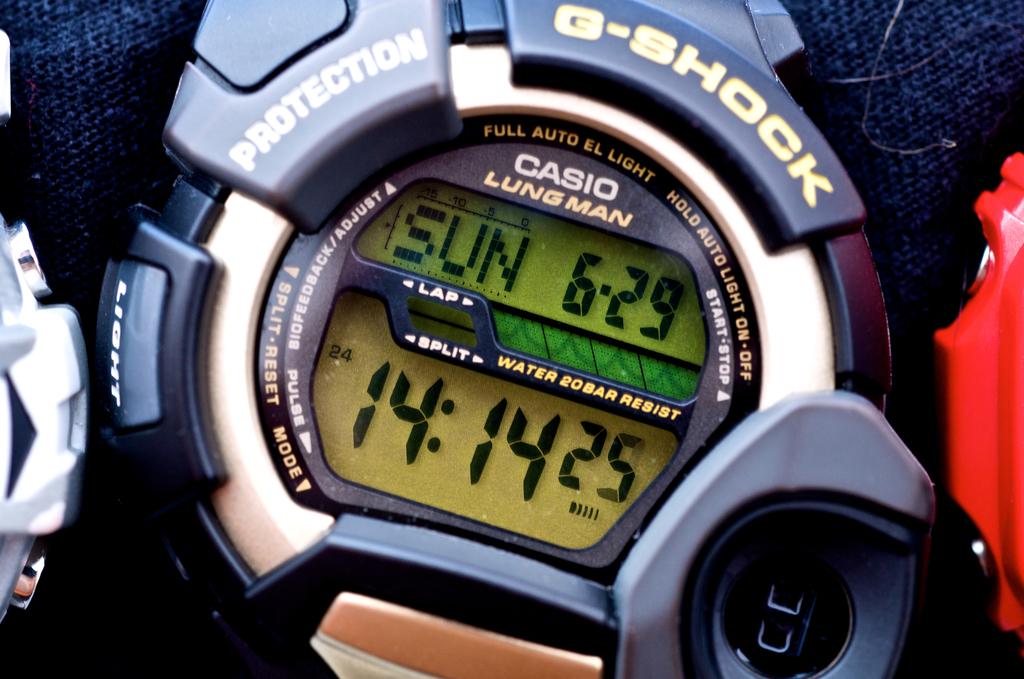What time is it?
Your response must be concise. 14:14. Is the casio lungman a waterproof watch?
Provide a succinct answer. Yes. 